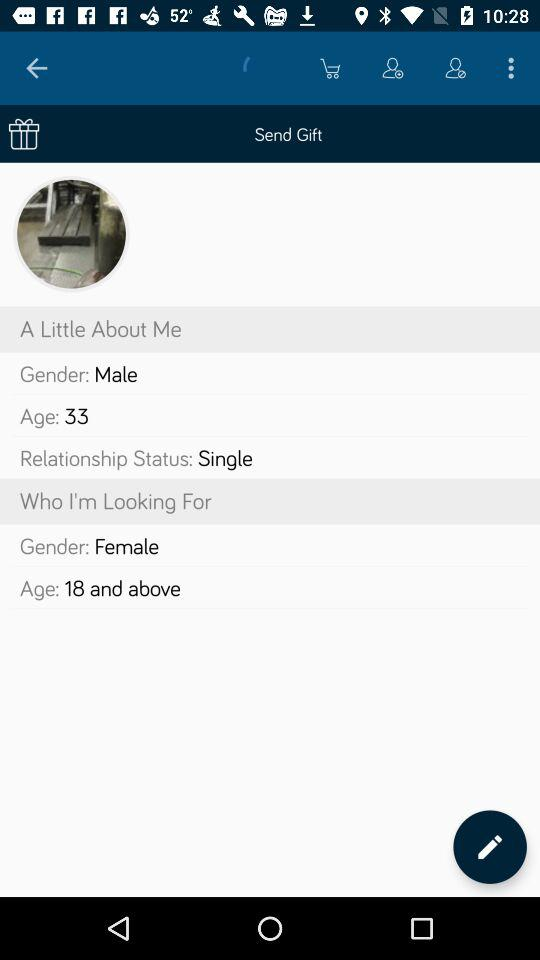What age am I looking for? You are looking for 18 and above. 